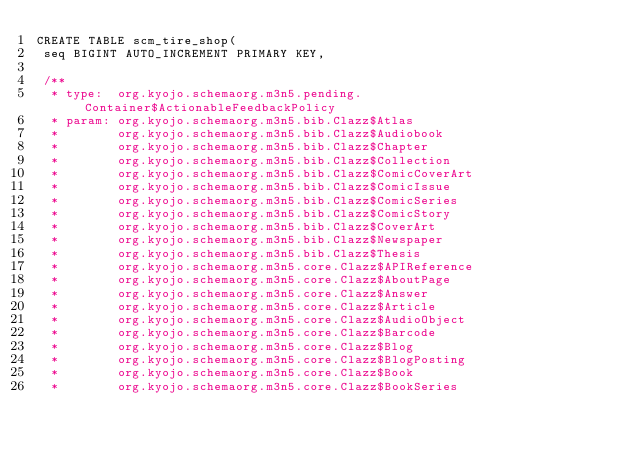<code> <loc_0><loc_0><loc_500><loc_500><_SQL_>CREATE TABLE scm_tire_shop(
 seq BIGINT AUTO_INCREMENT PRIMARY KEY,

 /**
  * type:  org.kyojo.schemaorg.m3n5.pending.Container$ActionableFeedbackPolicy
  * param: org.kyojo.schemaorg.m3n5.bib.Clazz$Atlas
  *        org.kyojo.schemaorg.m3n5.bib.Clazz$Audiobook
  *        org.kyojo.schemaorg.m3n5.bib.Clazz$Chapter
  *        org.kyojo.schemaorg.m3n5.bib.Clazz$Collection
  *        org.kyojo.schemaorg.m3n5.bib.Clazz$ComicCoverArt
  *        org.kyojo.schemaorg.m3n5.bib.Clazz$ComicIssue
  *        org.kyojo.schemaorg.m3n5.bib.Clazz$ComicSeries
  *        org.kyojo.schemaorg.m3n5.bib.Clazz$ComicStory
  *        org.kyojo.schemaorg.m3n5.bib.Clazz$CoverArt
  *        org.kyojo.schemaorg.m3n5.bib.Clazz$Newspaper
  *        org.kyojo.schemaorg.m3n5.bib.Clazz$Thesis
  *        org.kyojo.schemaorg.m3n5.core.Clazz$APIReference
  *        org.kyojo.schemaorg.m3n5.core.Clazz$AboutPage
  *        org.kyojo.schemaorg.m3n5.core.Clazz$Answer
  *        org.kyojo.schemaorg.m3n5.core.Clazz$Article
  *        org.kyojo.schemaorg.m3n5.core.Clazz$AudioObject
  *        org.kyojo.schemaorg.m3n5.core.Clazz$Barcode
  *        org.kyojo.schemaorg.m3n5.core.Clazz$Blog
  *        org.kyojo.schemaorg.m3n5.core.Clazz$BlogPosting
  *        org.kyojo.schemaorg.m3n5.core.Clazz$Book
  *        org.kyojo.schemaorg.m3n5.core.Clazz$BookSeries</code> 